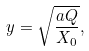Convert formula to latex. <formula><loc_0><loc_0><loc_500><loc_500>y = \sqrt { \frac { a Q } { X _ { 0 } } } ,</formula> 